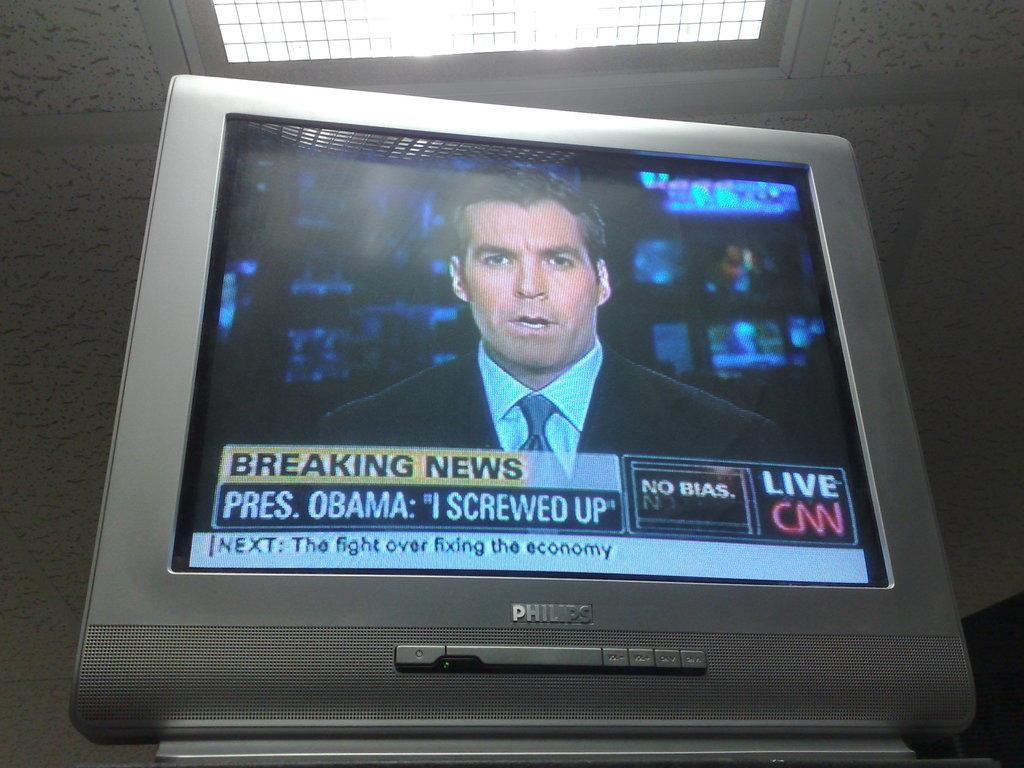<image>
Offer a succinct explanation of the picture presented. CNN is reporting that President Obama said he screwed up. 